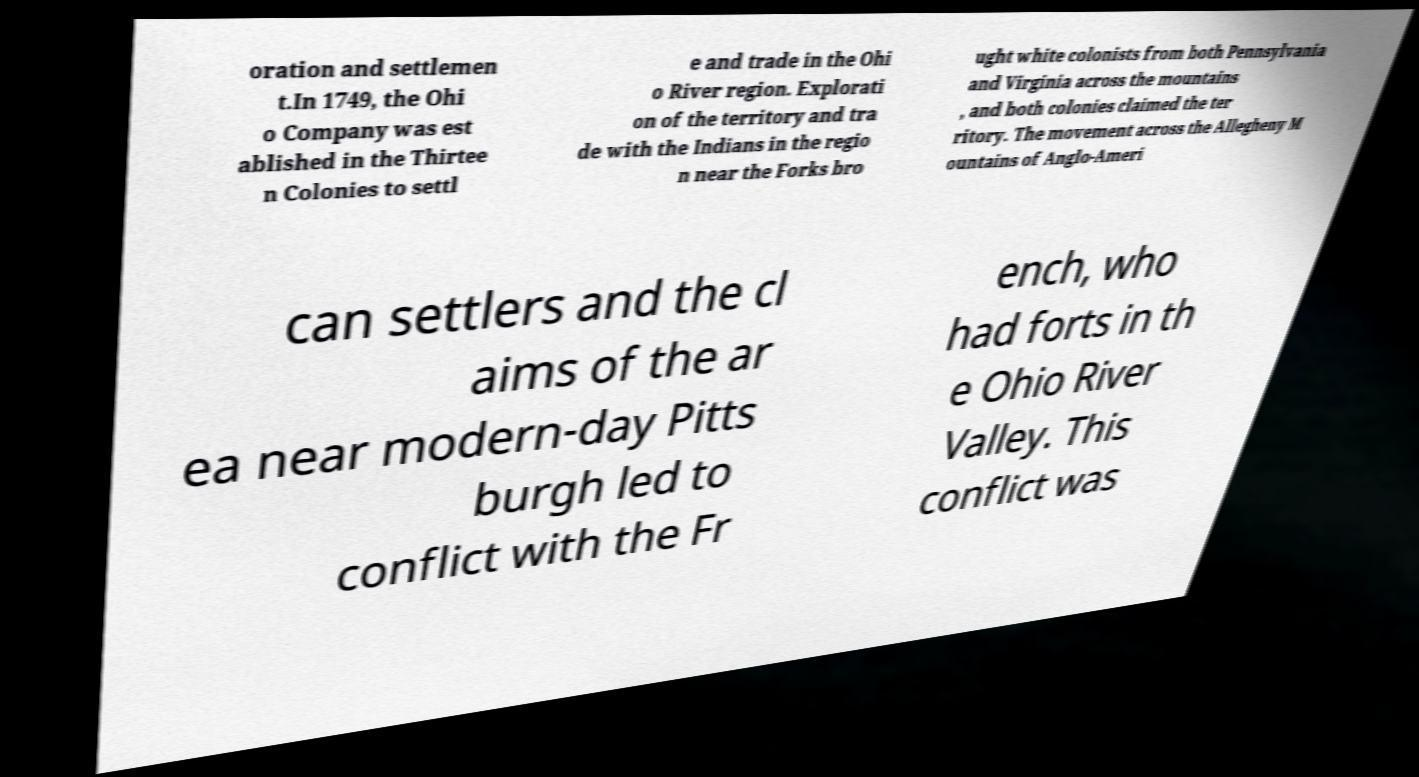There's text embedded in this image that I need extracted. Can you transcribe it verbatim? oration and settlemen t.In 1749, the Ohi o Company was est ablished in the Thirtee n Colonies to settl e and trade in the Ohi o River region. Explorati on of the territory and tra de with the Indians in the regio n near the Forks bro ught white colonists from both Pennsylvania and Virginia across the mountains , and both colonies claimed the ter ritory. The movement across the Allegheny M ountains of Anglo-Ameri can settlers and the cl aims of the ar ea near modern-day Pitts burgh led to conflict with the Fr ench, who had forts in th e Ohio River Valley. This conflict was 